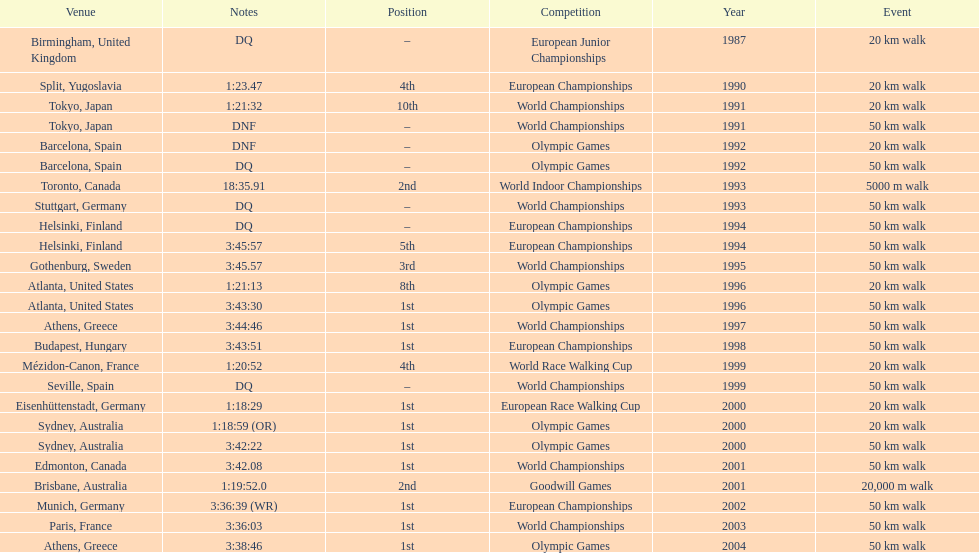How long did it take to walk 50 km in the 2004 olympic games? 3:38:46. 